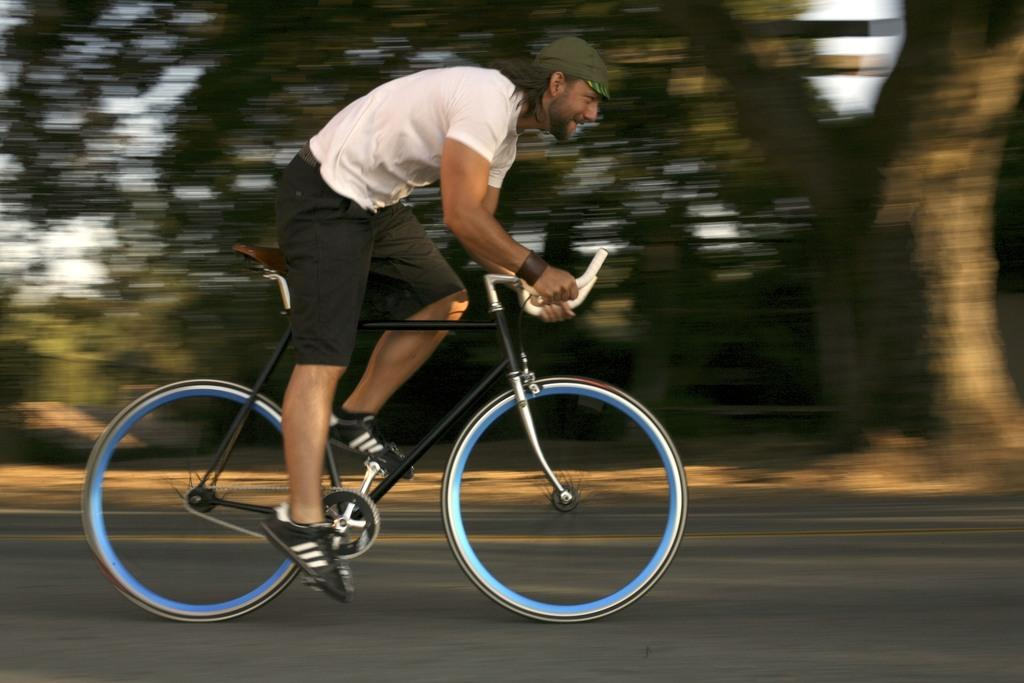Where was the image taken? The image is taken outdoors. What is the man in the image doing? The man is bicycling on the road. What type of clothing is the man wearing on his feet? The man is wearing shoes. What color is the shirt the man is wearing? The man is wearing a white shirt. What type of pants is the man wearing? The man is wearing a short. What can be seen beside the road in the image? There are many trees beside the road. What type of popcorn is the man eating while bicycling in the image? There is no popcorn present in the image; the man is bicycling and not eating anything. 